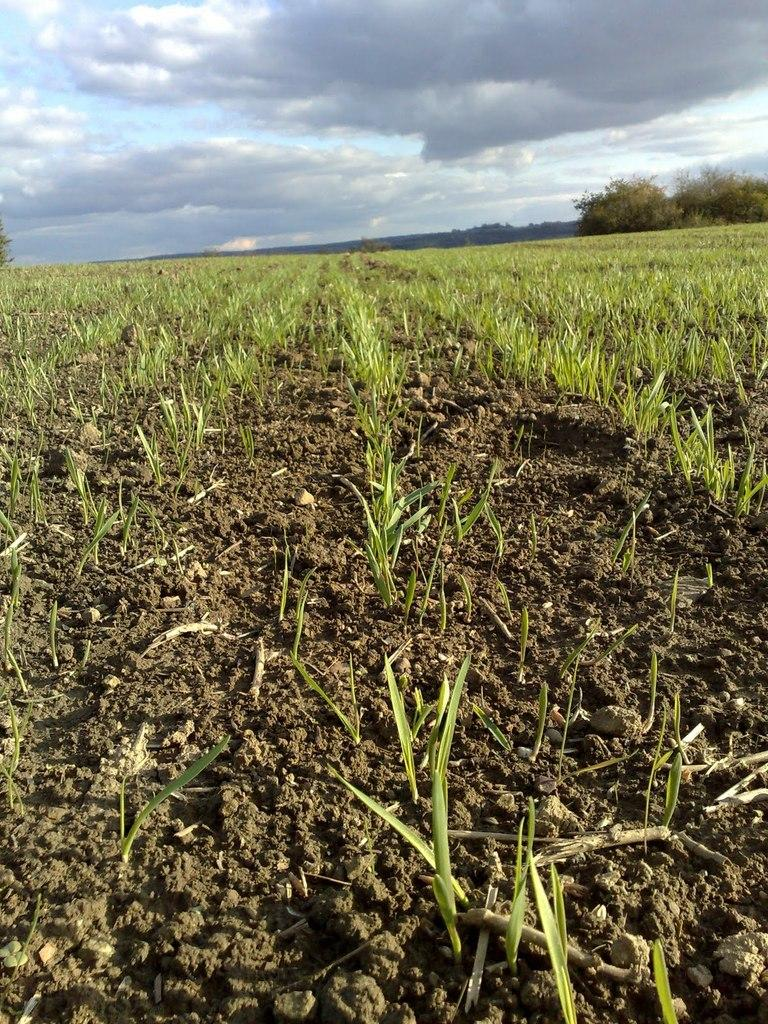What type of landscape is depicted in the image? The image contains farmland. What can be seen on the left side of the image? There is grass on the left side of the image. What is visible in the background of the image? There are trees and a mountain in the background of the image. What is visible at the top of the image? The sky is visible at the top of the image. What can be observed in the sky? Clouds are present in the sky. How many bikes are parked near the trees in the image? There are no bikes present in the image; it features farmland, grass, trees, a mountain, and clouds in the sky. What type of class is being taught in the field in the image? There is no class or teaching activity depicted in the image; it shows a natural landscape with farmland, grass, trees, a mountain, and clouds in the sky. 